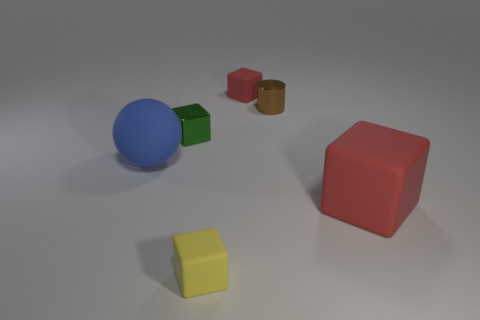Are there any other things that have the same size as the green metal cube?
Offer a terse response. Yes. How many other things are there of the same size as the brown metal thing?
Your answer should be very brief. 3. Does the big matte ball have the same color as the tiny metal cylinder?
Provide a succinct answer. No. There is a tiny thing in front of the metallic object that is left of the tiny rubber cube in front of the big red rubber cube; what shape is it?
Offer a terse response. Cube. What number of objects are either things that are on the right side of the tiny green cube or blocks that are to the left of the brown metal cylinder?
Ensure brevity in your answer.  5. What is the size of the red rubber block that is in front of the matte object that is behind the large blue rubber sphere?
Offer a terse response. Large. There is a block to the right of the small red block; is its color the same as the ball?
Provide a succinct answer. No. Are there any small brown things of the same shape as the big red rubber object?
Your response must be concise. No. What color is the matte cube that is the same size as the blue rubber object?
Give a very brief answer. Red. What size is the rubber thing behind the brown thing?
Keep it short and to the point. Small. 